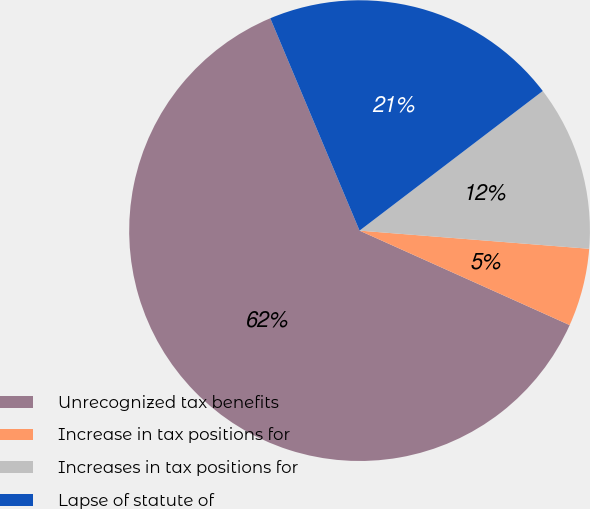Convert chart. <chart><loc_0><loc_0><loc_500><loc_500><pie_chart><fcel>Unrecognized tax benefits<fcel>Increase in tax positions for<fcel>Increases in tax positions for<fcel>Lapse of statute of<nl><fcel>61.94%<fcel>5.47%<fcel>11.62%<fcel>20.97%<nl></chart> 